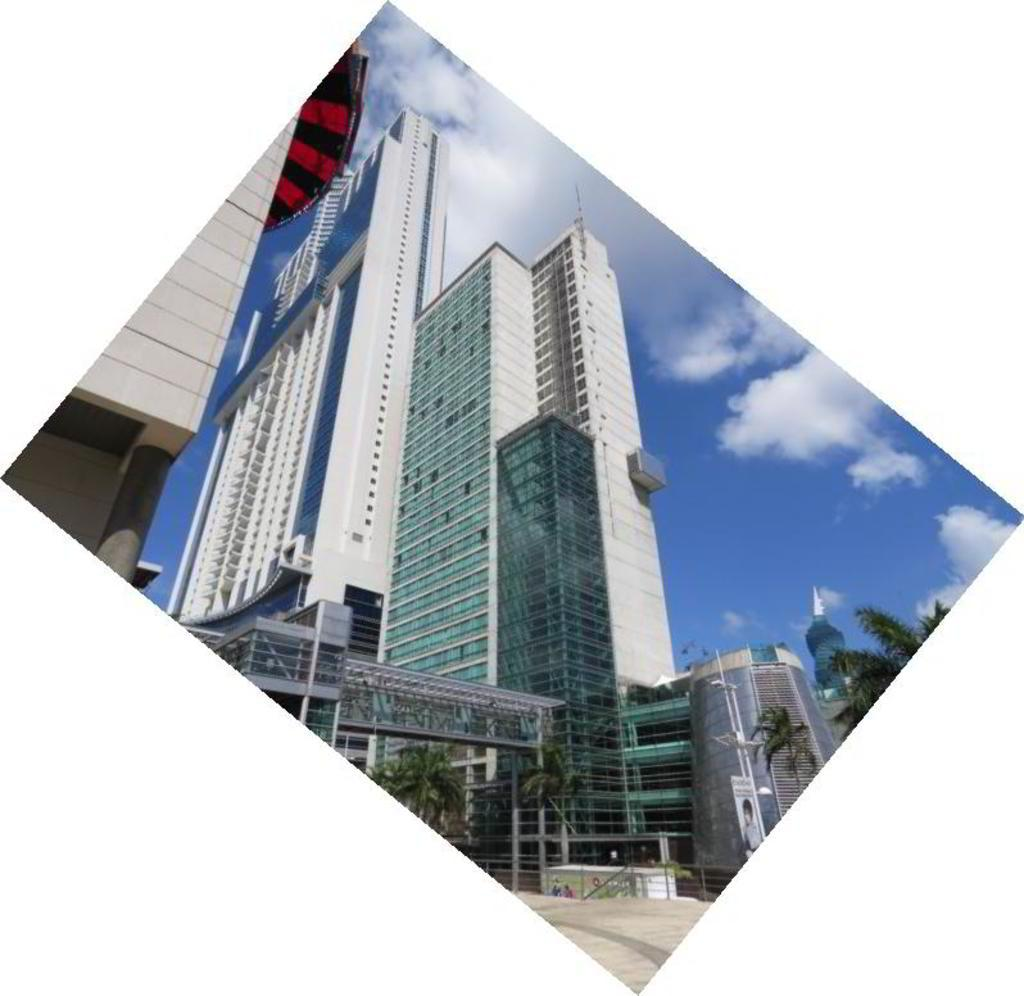What can be seen in the foreground area of the image? In the foreground area of the image, there are buildings, trees, posters, a pole, and the sky. Can you describe the buildings in the foreground area of the image? The buildings in the foreground area of the image are not described in detail, but they are present. What type of vegetation is visible in the foreground area of the image? Trees are the type of vegetation visible in the foreground area of the image. What is attached to the pole in the foreground area of the image? The provided facts do not mention anything attached to the pole, so we cannot answer that question. What time of day is it in the image, specifically in the afternoon? The provided facts do not mention the time of day, so we cannot determine if it is afternoon in the image. Can you describe the map on the window in the image? There is no map or window mentioned in the provided facts, so we cannot answer that question. 